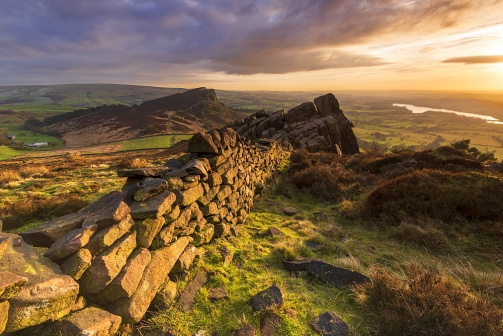Describe the atmosphere and mood of the scene depicted in the image. The scene in the image exudes a sense of tranquility and timelessness. The warm colors of the sunrise or sunset create an inviting, golden glow that envelops the entire landscape. The calmness of the lake, coupled with the soft shadows cast by the stone wall and surrounding hills, enhances the peaceful ambiance. The untouched, natural beauty of the valley, bathed in gentle light, evokes a sense of serenity and introspection, making one feel connected to the timeless rhythms of nature. What might the stone wall and rocky outcrop symbolize in this serene landscape? The stone wall and rocky outcrop could symbolize strength and resilience in the face of time and nature's elements. The wall, made from large, irregular stones, represents human effort and craftsmanship, standing firm against the forces of erosion and weathering. The rocky outcrop, with its rugged and imposing presence, represents the enduring, unyielding aspects of nature. Together, they highlight a harmonious coexistence between human endeavors and the natural world, each adding to the beauty and character of the landscape. 